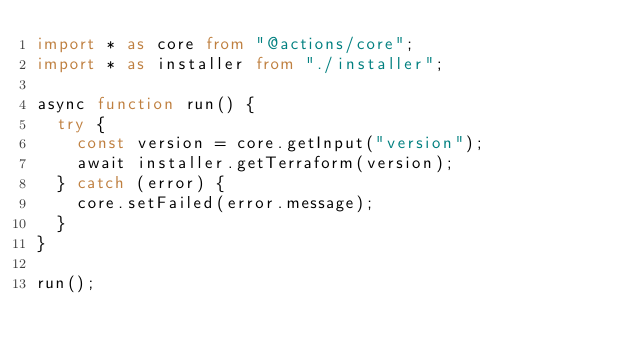<code> <loc_0><loc_0><loc_500><loc_500><_TypeScript_>import * as core from "@actions/core";
import * as installer from "./installer";

async function run() {
  try {
    const version = core.getInput("version");
    await installer.getTerraform(version);
  } catch (error) {
    core.setFailed(error.message);
  }
}

run();
</code> 